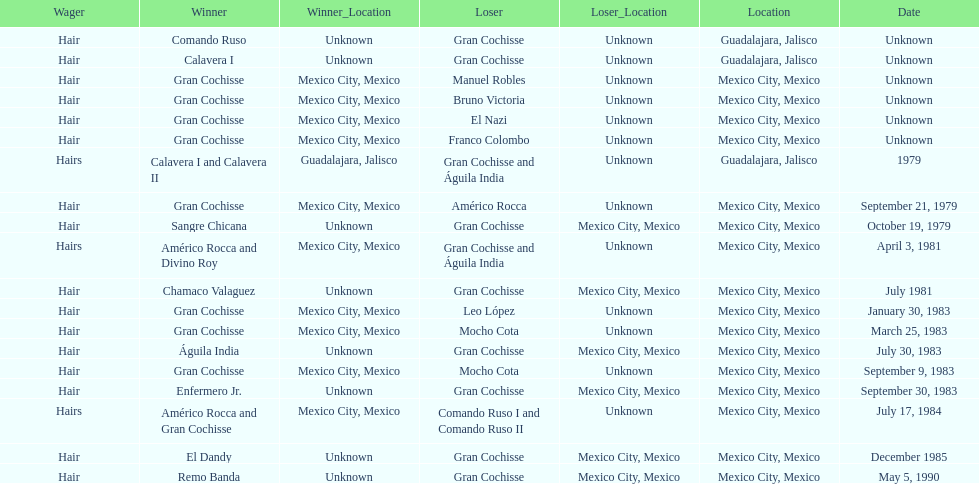Can you parse all the data within this table? {'header': ['Wager', 'Winner', 'Winner_Location', 'Loser', 'Loser_Location', 'Location', 'Date'], 'rows': [['Hair', 'Comando Ruso', 'Unknown', 'Gran Cochisse', 'Unknown', 'Guadalajara, Jalisco', 'Unknown'], ['Hair', 'Calavera I', 'Unknown', 'Gran Cochisse', 'Unknown', 'Guadalajara, Jalisco', 'Unknown'], ['Hair', 'Gran Cochisse', 'Mexico City, Mexico', 'Manuel Robles', 'Unknown', 'Mexico City, Mexico', 'Unknown'], ['Hair', 'Gran Cochisse', 'Mexico City, Mexico', 'Bruno Victoria', 'Unknown', 'Mexico City, Mexico', 'Unknown'], ['Hair', 'Gran Cochisse', 'Mexico City, Mexico', 'El Nazi', 'Unknown', 'Mexico City, Mexico', 'Unknown'], ['Hair', 'Gran Cochisse', 'Mexico City, Mexico', 'Franco Colombo', 'Unknown', 'Mexico City, Mexico', 'Unknown'], ['Hairs', 'Calavera I and Calavera II', 'Guadalajara, Jalisco', 'Gran Cochisse and Águila India', 'Unknown', 'Guadalajara, Jalisco', '1979'], ['Hair', 'Gran Cochisse', 'Mexico City, Mexico', 'Américo Rocca', 'Unknown', 'Mexico City, Mexico', 'September 21, 1979'], ['Hair', 'Sangre Chicana', 'Unknown', 'Gran Cochisse', 'Mexico City, Mexico', 'Mexico City, Mexico', 'October 19, 1979'], ['Hairs', 'Américo Rocca and Divino Roy', 'Mexico City, Mexico', 'Gran Cochisse and Águila India', 'Unknown', 'Mexico City, Mexico', 'April 3, 1981'], ['Hair', 'Chamaco Valaguez', 'Unknown', 'Gran Cochisse', 'Mexico City, Mexico', 'Mexico City, Mexico', 'July 1981'], ['Hair', 'Gran Cochisse', 'Mexico City, Mexico', 'Leo López', 'Unknown', 'Mexico City, Mexico', 'January 30, 1983'], ['Hair', 'Gran Cochisse', 'Mexico City, Mexico', 'Mocho Cota', 'Unknown', 'Mexico City, Mexico', 'March 25, 1983'], ['Hair', 'Águila India', 'Unknown', 'Gran Cochisse', 'Mexico City, Mexico', 'Mexico City, Mexico', 'July 30, 1983'], ['Hair', 'Gran Cochisse', 'Mexico City, Mexico', 'Mocho Cota', 'Unknown', 'Mexico City, Mexico', 'September 9, 1983'], ['Hair', 'Enfermero Jr.', 'Unknown', 'Gran Cochisse', 'Mexico City, Mexico', 'Mexico City, Mexico', 'September 30, 1983'], ['Hairs', 'Américo Rocca and Gran Cochisse', 'Mexico City, Mexico', 'Comando Ruso I and Comando Ruso II', 'Unknown', 'Mexico City, Mexico', 'July 17, 1984'], ['Hair', 'El Dandy', 'Unknown', 'Gran Cochisse', 'Mexico City, Mexico', 'Mexico City, Mexico', 'December 1985'], ['Hair', 'Remo Banda', 'Unknown', 'Gran Cochisse', 'Mexico City, Mexico', 'Mexico City, Mexico', 'May 5, 1990']]} How many times has gran cochisse been a winner? 9. 